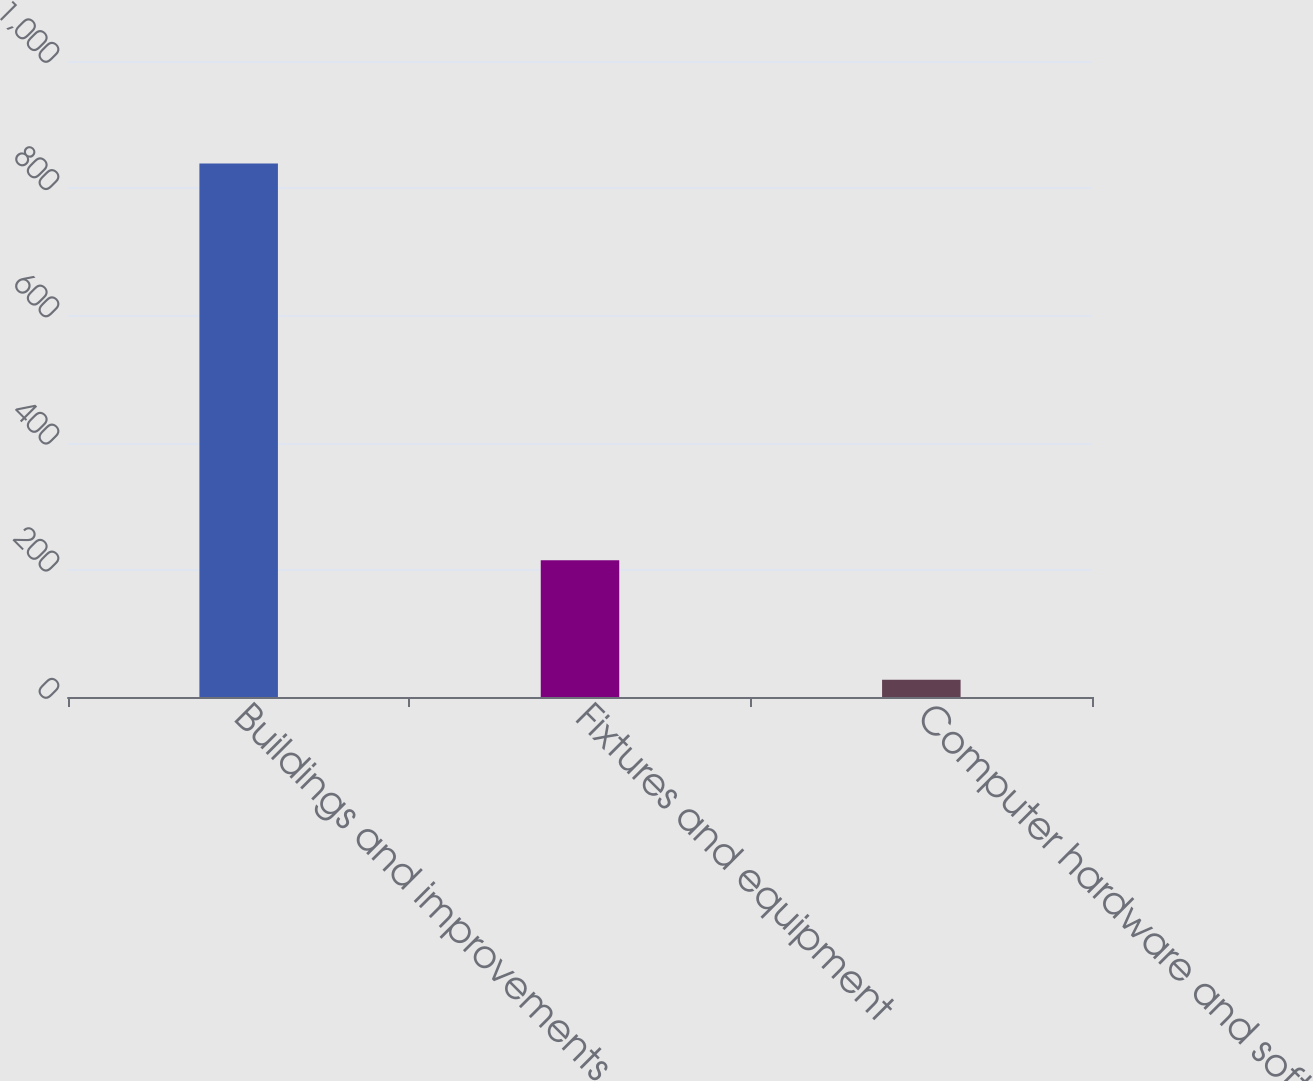Convert chart to OTSL. <chart><loc_0><loc_0><loc_500><loc_500><bar_chart><fcel>Buildings and improvements<fcel>Fixtures and equipment<fcel>Computer hardware and software<nl><fcel>839<fcel>215<fcel>27<nl></chart> 